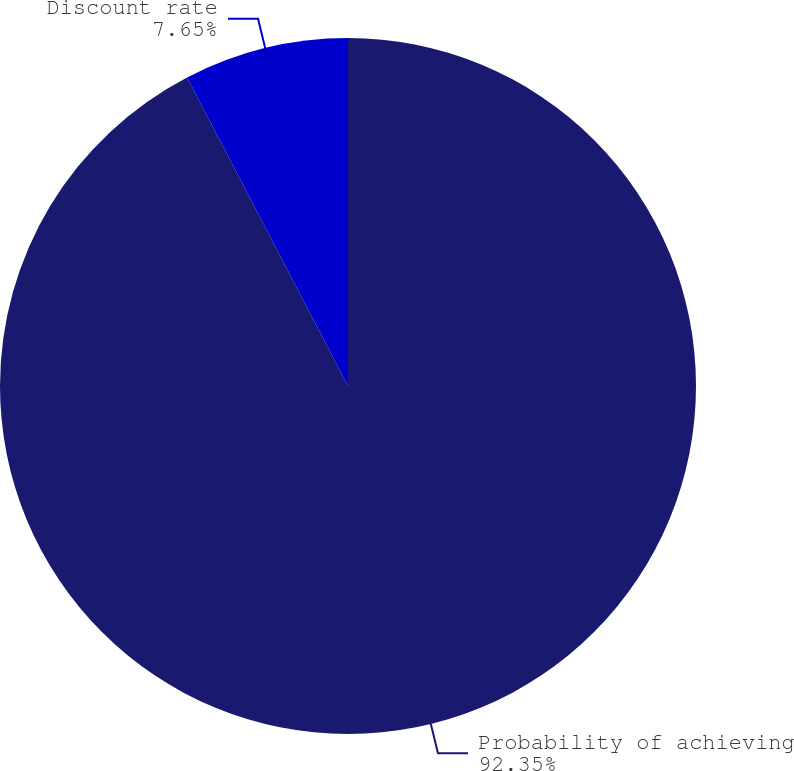<chart> <loc_0><loc_0><loc_500><loc_500><pie_chart><fcel>Probability of achieving<fcel>Discount rate<nl><fcel>92.35%<fcel>7.65%<nl></chart> 